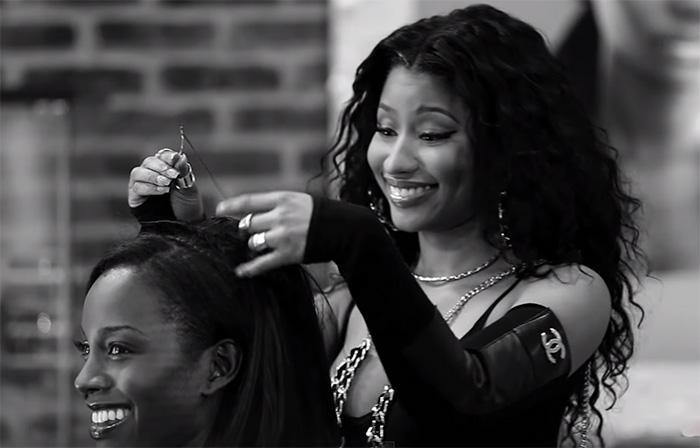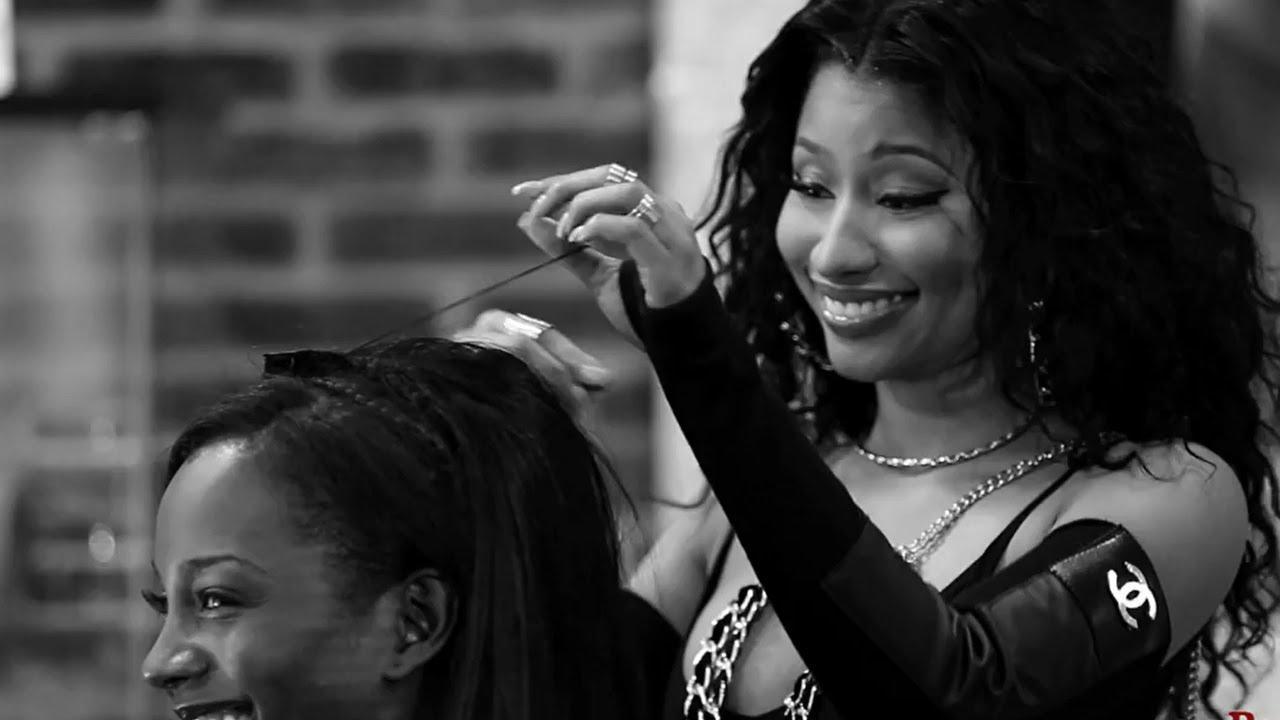The first image is the image on the left, the second image is the image on the right. Examine the images to the left and right. Is the description "Left image shows a stylist behind a customer wearing a red smock, and right image shows a front-facing woman who is not styling hair." accurate? Answer yes or no. No. The first image is the image on the left, the second image is the image on the right. Considering the images on both sides, is "A woman is doing another woman's hair in only one of the images." valid? Answer yes or no. No. 